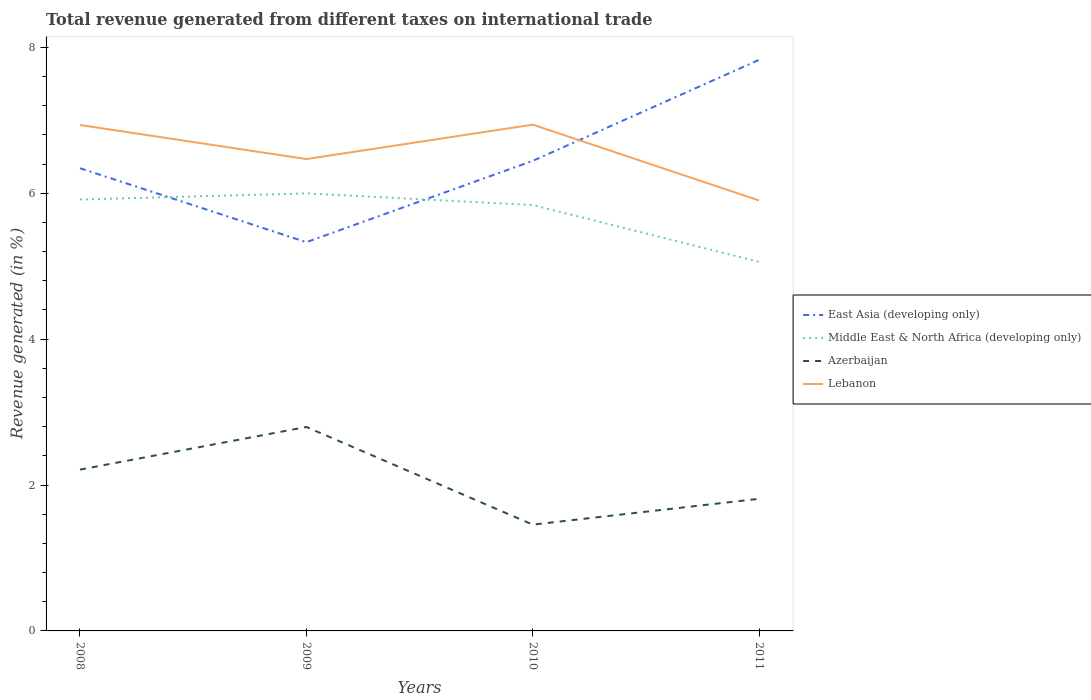How many different coloured lines are there?
Provide a short and direct response. 4. Across all years, what is the maximum total revenue generated in Azerbaijan?
Provide a succinct answer. 1.46. What is the total total revenue generated in East Asia (developing only) in the graph?
Provide a short and direct response. 1.01. What is the difference between the highest and the second highest total revenue generated in Middle East & North Africa (developing only)?
Your answer should be very brief. 0.94. What is the difference between the highest and the lowest total revenue generated in Azerbaijan?
Keep it short and to the point. 2. Is the total revenue generated in Middle East & North Africa (developing only) strictly greater than the total revenue generated in Azerbaijan over the years?
Make the answer very short. No. How many lines are there?
Ensure brevity in your answer.  4. Are the values on the major ticks of Y-axis written in scientific E-notation?
Offer a terse response. No. Does the graph contain any zero values?
Give a very brief answer. No. How many legend labels are there?
Give a very brief answer. 4. How are the legend labels stacked?
Provide a succinct answer. Vertical. What is the title of the graph?
Provide a short and direct response. Total revenue generated from different taxes on international trade. What is the label or title of the X-axis?
Make the answer very short. Years. What is the label or title of the Y-axis?
Offer a terse response. Revenue generated (in %). What is the Revenue generated (in %) in East Asia (developing only) in 2008?
Provide a short and direct response. 6.34. What is the Revenue generated (in %) of Middle East & North Africa (developing only) in 2008?
Your answer should be compact. 5.91. What is the Revenue generated (in %) in Azerbaijan in 2008?
Provide a succinct answer. 2.21. What is the Revenue generated (in %) in Lebanon in 2008?
Offer a terse response. 6.93. What is the Revenue generated (in %) of East Asia (developing only) in 2009?
Offer a terse response. 5.33. What is the Revenue generated (in %) in Middle East & North Africa (developing only) in 2009?
Ensure brevity in your answer.  6. What is the Revenue generated (in %) of Azerbaijan in 2009?
Offer a terse response. 2.8. What is the Revenue generated (in %) of Lebanon in 2009?
Keep it short and to the point. 6.47. What is the Revenue generated (in %) in East Asia (developing only) in 2010?
Your answer should be compact. 6.44. What is the Revenue generated (in %) of Middle East & North Africa (developing only) in 2010?
Make the answer very short. 5.84. What is the Revenue generated (in %) of Azerbaijan in 2010?
Keep it short and to the point. 1.46. What is the Revenue generated (in %) in Lebanon in 2010?
Give a very brief answer. 6.94. What is the Revenue generated (in %) in East Asia (developing only) in 2011?
Offer a very short reply. 7.83. What is the Revenue generated (in %) of Middle East & North Africa (developing only) in 2011?
Your answer should be compact. 5.06. What is the Revenue generated (in %) of Azerbaijan in 2011?
Make the answer very short. 1.81. What is the Revenue generated (in %) in Lebanon in 2011?
Provide a short and direct response. 5.9. Across all years, what is the maximum Revenue generated (in %) of East Asia (developing only)?
Provide a succinct answer. 7.83. Across all years, what is the maximum Revenue generated (in %) in Middle East & North Africa (developing only)?
Your answer should be compact. 6. Across all years, what is the maximum Revenue generated (in %) in Azerbaijan?
Keep it short and to the point. 2.8. Across all years, what is the maximum Revenue generated (in %) in Lebanon?
Your answer should be very brief. 6.94. Across all years, what is the minimum Revenue generated (in %) of East Asia (developing only)?
Offer a terse response. 5.33. Across all years, what is the minimum Revenue generated (in %) in Middle East & North Africa (developing only)?
Offer a very short reply. 5.06. Across all years, what is the minimum Revenue generated (in %) of Azerbaijan?
Your answer should be compact. 1.46. Across all years, what is the minimum Revenue generated (in %) of Lebanon?
Provide a short and direct response. 5.9. What is the total Revenue generated (in %) of East Asia (developing only) in the graph?
Provide a short and direct response. 25.94. What is the total Revenue generated (in %) in Middle East & North Africa (developing only) in the graph?
Make the answer very short. 22.81. What is the total Revenue generated (in %) of Azerbaijan in the graph?
Your answer should be compact. 8.28. What is the total Revenue generated (in %) in Lebanon in the graph?
Make the answer very short. 26.24. What is the difference between the Revenue generated (in %) of East Asia (developing only) in 2008 and that in 2009?
Provide a succinct answer. 1.01. What is the difference between the Revenue generated (in %) of Middle East & North Africa (developing only) in 2008 and that in 2009?
Your answer should be very brief. -0.08. What is the difference between the Revenue generated (in %) of Azerbaijan in 2008 and that in 2009?
Your answer should be very brief. -0.58. What is the difference between the Revenue generated (in %) of Lebanon in 2008 and that in 2009?
Keep it short and to the point. 0.47. What is the difference between the Revenue generated (in %) of East Asia (developing only) in 2008 and that in 2010?
Offer a very short reply. -0.1. What is the difference between the Revenue generated (in %) of Middle East & North Africa (developing only) in 2008 and that in 2010?
Your answer should be compact. 0.08. What is the difference between the Revenue generated (in %) of Azerbaijan in 2008 and that in 2010?
Provide a succinct answer. 0.75. What is the difference between the Revenue generated (in %) of Lebanon in 2008 and that in 2010?
Offer a very short reply. -0. What is the difference between the Revenue generated (in %) in East Asia (developing only) in 2008 and that in 2011?
Offer a terse response. -1.49. What is the difference between the Revenue generated (in %) of Middle East & North Africa (developing only) in 2008 and that in 2011?
Keep it short and to the point. 0.86. What is the difference between the Revenue generated (in %) of Lebanon in 2008 and that in 2011?
Your response must be concise. 1.03. What is the difference between the Revenue generated (in %) in East Asia (developing only) in 2009 and that in 2010?
Your answer should be very brief. -1.12. What is the difference between the Revenue generated (in %) in Middle East & North Africa (developing only) in 2009 and that in 2010?
Make the answer very short. 0.16. What is the difference between the Revenue generated (in %) in Azerbaijan in 2009 and that in 2010?
Your response must be concise. 1.34. What is the difference between the Revenue generated (in %) of Lebanon in 2009 and that in 2010?
Offer a terse response. -0.47. What is the difference between the Revenue generated (in %) of East Asia (developing only) in 2009 and that in 2011?
Your answer should be very brief. -2.5. What is the difference between the Revenue generated (in %) of Middle East & North Africa (developing only) in 2009 and that in 2011?
Ensure brevity in your answer.  0.94. What is the difference between the Revenue generated (in %) of Azerbaijan in 2009 and that in 2011?
Offer a very short reply. 0.98. What is the difference between the Revenue generated (in %) of Lebanon in 2009 and that in 2011?
Give a very brief answer. 0.57. What is the difference between the Revenue generated (in %) in East Asia (developing only) in 2010 and that in 2011?
Offer a very short reply. -1.38. What is the difference between the Revenue generated (in %) in Middle East & North Africa (developing only) in 2010 and that in 2011?
Give a very brief answer. 0.78. What is the difference between the Revenue generated (in %) in Azerbaijan in 2010 and that in 2011?
Ensure brevity in your answer.  -0.35. What is the difference between the Revenue generated (in %) of Lebanon in 2010 and that in 2011?
Your answer should be very brief. 1.04. What is the difference between the Revenue generated (in %) in East Asia (developing only) in 2008 and the Revenue generated (in %) in Middle East & North Africa (developing only) in 2009?
Keep it short and to the point. 0.34. What is the difference between the Revenue generated (in %) of East Asia (developing only) in 2008 and the Revenue generated (in %) of Azerbaijan in 2009?
Your response must be concise. 3.55. What is the difference between the Revenue generated (in %) in East Asia (developing only) in 2008 and the Revenue generated (in %) in Lebanon in 2009?
Make the answer very short. -0.13. What is the difference between the Revenue generated (in %) in Middle East & North Africa (developing only) in 2008 and the Revenue generated (in %) in Azerbaijan in 2009?
Make the answer very short. 3.12. What is the difference between the Revenue generated (in %) of Middle East & North Africa (developing only) in 2008 and the Revenue generated (in %) of Lebanon in 2009?
Keep it short and to the point. -0.55. What is the difference between the Revenue generated (in %) in Azerbaijan in 2008 and the Revenue generated (in %) in Lebanon in 2009?
Offer a very short reply. -4.26. What is the difference between the Revenue generated (in %) in East Asia (developing only) in 2008 and the Revenue generated (in %) in Middle East & North Africa (developing only) in 2010?
Make the answer very short. 0.5. What is the difference between the Revenue generated (in %) of East Asia (developing only) in 2008 and the Revenue generated (in %) of Azerbaijan in 2010?
Offer a terse response. 4.89. What is the difference between the Revenue generated (in %) of East Asia (developing only) in 2008 and the Revenue generated (in %) of Lebanon in 2010?
Make the answer very short. -0.6. What is the difference between the Revenue generated (in %) in Middle East & North Africa (developing only) in 2008 and the Revenue generated (in %) in Azerbaijan in 2010?
Your answer should be very brief. 4.46. What is the difference between the Revenue generated (in %) in Middle East & North Africa (developing only) in 2008 and the Revenue generated (in %) in Lebanon in 2010?
Offer a very short reply. -1.03. What is the difference between the Revenue generated (in %) in Azerbaijan in 2008 and the Revenue generated (in %) in Lebanon in 2010?
Your response must be concise. -4.73. What is the difference between the Revenue generated (in %) in East Asia (developing only) in 2008 and the Revenue generated (in %) in Middle East & North Africa (developing only) in 2011?
Keep it short and to the point. 1.28. What is the difference between the Revenue generated (in %) of East Asia (developing only) in 2008 and the Revenue generated (in %) of Azerbaijan in 2011?
Your response must be concise. 4.53. What is the difference between the Revenue generated (in %) in East Asia (developing only) in 2008 and the Revenue generated (in %) in Lebanon in 2011?
Your answer should be compact. 0.44. What is the difference between the Revenue generated (in %) of Middle East & North Africa (developing only) in 2008 and the Revenue generated (in %) of Azerbaijan in 2011?
Ensure brevity in your answer.  4.1. What is the difference between the Revenue generated (in %) in Middle East & North Africa (developing only) in 2008 and the Revenue generated (in %) in Lebanon in 2011?
Your response must be concise. 0.01. What is the difference between the Revenue generated (in %) of Azerbaijan in 2008 and the Revenue generated (in %) of Lebanon in 2011?
Offer a very short reply. -3.69. What is the difference between the Revenue generated (in %) of East Asia (developing only) in 2009 and the Revenue generated (in %) of Middle East & North Africa (developing only) in 2010?
Keep it short and to the point. -0.51. What is the difference between the Revenue generated (in %) of East Asia (developing only) in 2009 and the Revenue generated (in %) of Azerbaijan in 2010?
Offer a terse response. 3.87. What is the difference between the Revenue generated (in %) of East Asia (developing only) in 2009 and the Revenue generated (in %) of Lebanon in 2010?
Ensure brevity in your answer.  -1.61. What is the difference between the Revenue generated (in %) in Middle East & North Africa (developing only) in 2009 and the Revenue generated (in %) in Azerbaijan in 2010?
Provide a succinct answer. 4.54. What is the difference between the Revenue generated (in %) of Middle East & North Africa (developing only) in 2009 and the Revenue generated (in %) of Lebanon in 2010?
Your response must be concise. -0.94. What is the difference between the Revenue generated (in %) of Azerbaijan in 2009 and the Revenue generated (in %) of Lebanon in 2010?
Your answer should be very brief. -4.14. What is the difference between the Revenue generated (in %) in East Asia (developing only) in 2009 and the Revenue generated (in %) in Middle East & North Africa (developing only) in 2011?
Offer a very short reply. 0.27. What is the difference between the Revenue generated (in %) of East Asia (developing only) in 2009 and the Revenue generated (in %) of Azerbaijan in 2011?
Offer a terse response. 3.52. What is the difference between the Revenue generated (in %) in East Asia (developing only) in 2009 and the Revenue generated (in %) in Lebanon in 2011?
Your response must be concise. -0.57. What is the difference between the Revenue generated (in %) of Middle East & North Africa (developing only) in 2009 and the Revenue generated (in %) of Azerbaijan in 2011?
Keep it short and to the point. 4.19. What is the difference between the Revenue generated (in %) of Middle East & North Africa (developing only) in 2009 and the Revenue generated (in %) of Lebanon in 2011?
Your answer should be very brief. 0.1. What is the difference between the Revenue generated (in %) in Azerbaijan in 2009 and the Revenue generated (in %) in Lebanon in 2011?
Your answer should be compact. -3.1. What is the difference between the Revenue generated (in %) of East Asia (developing only) in 2010 and the Revenue generated (in %) of Middle East & North Africa (developing only) in 2011?
Make the answer very short. 1.39. What is the difference between the Revenue generated (in %) of East Asia (developing only) in 2010 and the Revenue generated (in %) of Azerbaijan in 2011?
Give a very brief answer. 4.63. What is the difference between the Revenue generated (in %) of East Asia (developing only) in 2010 and the Revenue generated (in %) of Lebanon in 2011?
Offer a terse response. 0.54. What is the difference between the Revenue generated (in %) in Middle East & North Africa (developing only) in 2010 and the Revenue generated (in %) in Azerbaijan in 2011?
Your answer should be compact. 4.03. What is the difference between the Revenue generated (in %) in Middle East & North Africa (developing only) in 2010 and the Revenue generated (in %) in Lebanon in 2011?
Offer a very short reply. -0.06. What is the difference between the Revenue generated (in %) of Azerbaijan in 2010 and the Revenue generated (in %) of Lebanon in 2011?
Offer a terse response. -4.44. What is the average Revenue generated (in %) in East Asia (developing only) per year?
Provide a succinct answer. 6.49. What is the average Revenue generated (in %) of Middle East & North Africa (developing only) per year?
Offer a very short reply. 5.7. What is the average Revenue generated (in %) of Azerbaijan per year?
Your response must be concise. 2.07. What is the average Revenue generated (in %) in Lebanon per year?
Keep it short and to the point. 6.56. In the year 2008, what is the difference between the Revenue generated (in %) in East Asia (developing only) and Revenue generated (in %) in Middle East & North Africa (developing only)?
Give a very brief answer. 0.43. In the year 2008, what is the difference between the Revenue generated (in %) in East Asia (developing only) and Revenue generated (in %) in Azerbaijan?
Make the answer very short. 4.13. In the year 2008, what is the difference between the Revenue generated (in %) in East Asia (developing only) and Revenue generated (in %) in Lebanon?
Make the answer very short. -0.59. In the year 2008, what is the difference between the Revenue generated (in %) in Middle East & North Africa (developing only) and Revenue generated (in %) in Azerbaijan?
Make the answer very short. 3.7. In the year 2008, what is the difference between the Revenue generated (in %) of Middle East & North Africa (developing only) and Revenue generated (in %) of Lebanon?
Offer a very short reply. -1.02. In the year 2008, what is the difference between the Revenue generated (in %) in Azerbaijan and Revenue generated (in %) in Lebanon?
Give a very brief answer. -4.72. In the year 2009, what is the difference between the Revenue generated (in %) of East Asia (developing only) and Revenue generated (in %) of Middle East & North Africa (developing only)?
Make the answer very short. -0.67. In the year 2009, what is the difference between the Revenue generated (in %) in East Asia (developing only) and Revenue generated (in %) in Azerbaijan?
Provide a succinct answer. 2.53. In the year 2009, what is the difference between the Revenue generated (in %) of East Asia (developing only) and Revenue generated (in %) of Lebanon?
Make the answer very short. -1.14. In the year 2009, what is the difference between the Revenue generated (in %) in Middle East & North Africa (developing only) and Revenue generated (in %) in Azerbaijan?
Give a very brief answer. 3.2. In the year 2009, what is the difference between the Revenue generated (in %) of Middle East & North Africa (developing only) and Revenue generated (in %) of Lebanon?
Provide a succinct answer. -0.47. In the year 2009, what is the difference between the Revenue generated (in %) of Azerbaijan and Revenue generated (in %) of Lebanon?
Keep it short and to the point. -3.67. In the year 2010, what is the difference between the Revenue generated (in %) in East Asia (developing only) and Revenue generated (in %) in Middle East & North Africa (developing only)?
Give a very brief answer. 0.61. In the year 2010, what is the difference between the Revenue generated (in %) in East Asia (developing only) and Revenue generated (in %) in Azerbaijan?
Provide a succinct answer. 4.99. In the year 2010, what is the difference between the Revenue generated (in %) of East Asia (developing only) and Revenue generated (in %) of Lebanon?
Offer a very short reply. -0.5. In the year 2010, what is the difference between the Revenue generated (in %) in Middle East & North Africa (developing only) and Revenue generated (in %) in Azerbaijan?
Your answer should be very brief. 4.38. In the year 2010, what is the difference between the Revenue generated (in %) of Middle East & North Africa (developing only) and Revenue generated (in %) of Lebanon?
Your answer should be compact. -1.1. In the year 2010, what is the difference between the Revenue generated (in %) of Azerbaijan and Revenue generated (in %) of Lebanon?
Offer a terse response. -5.48. In the year 2011, what is the difference between the Revenue generated (in %) in East Asia (developing only) and Revenue generated (in %) in Middle East & North Africa (developing only)?
Provide a short and direct response. 2.77. In the year 2011, what is the difference between the Revenue generated (in %) in East Asia (developing only) and Revenue generated (in %) in Azerbaijan?
Provide a succinct answer. 6.02. In the year 2011, what is the difference between the Revenue generated (in %) in East Asia (developing only) and Revenue generated (in %) in Lebanon?
Offer a terse response. 1.93. In the year 2011, what is the difference between the Revenue generated (in %) of Middle East & North Africa (developing only) and Revenue generated (in %) of Azerbaijan?
Offer a very short reply. 3.25. In the year 2011, what is the difference between the Revenue generated (in %) of Middle East & North Africa (developing only) and Revenue generated (in %) of Lebanon?
Give a very brief answer. -0.84. In the year 2011, what is the difference between the Revenue generated (in %) of Azerbaijan and Revenue generated (in %) of Lebanon?
Offer a terse response. -4.09. What is the ratio of the Revenue generated (in %) in East Asia (developing only) in 2008 to that in 2009?
Ensure brevity in your answer.  1.19. What is the ratio of the Revenue generated (in %) of Middle East & North Africa (developing only) in 2008 to that in 2009?
Your answer should be very brief. 0.99. What is the ratio of the Revenue generated (in %) of Azerbaijan in 2008 to that in 2009?
Provide a succinct answer. 0.79. What is the ratio of the Revenue generated (in %) of Lebanon in 2008 to that in 2009?
Offer a terse response. 1.07. What is the ratio of the Revenue generated (in %) of East Asia (developing only) in 2008 to that in 2010?
Keep it short and to the point. 0.98. What is the ratio of the Revenue generated (in %) in Middle East & North Africa (developing only) in 2008 to that in 2010?
Make the answer very short. 1.01. What is the ratio of the Revenue generated (in %) of Azerbaijan in 2008 to that in 2010?
Keep it short and to the point. 1.52. What is the ratio of the Revenue generated (in %) of Lebanon in 2008 to that in 2010?
Make the answer very short. 1. What is the ratio of the Revenue generated (in %) of East Asia (developing only) in 2008 to that in 2011?
Your response must be concise. 0.81. What is the ratio of the Revenue generated (in %) in Middle East & North Africa (developing only) in 2008 to that in 2011?
Your answer should be compact. 1.17. What is the ratio of the Revenue generated (in %) in Azerbaijan in 2008 to that in 2011?
Provide a short and direct response. 1.22. What is the ratio of the Revenue generated (in %) of Lebanon in 2008 to that in 2011?
Keep it short and to the point. 1.18. What is the ratio of the Revenue generated (in %) in East Asia (developing only) in 2009 to that in 2010?
Provide a short and direct response. 0.83. What is the ratio of the Revenue generated (in %) of Middle East & North Africa (developing only) in 2009 to that in 2010?
Keep it short and to the point. 1.03. What is the ratio of the Revenue generated (in %) in Azerbaijan in 2009 to that in 2010?
Offer a very short reply. 1.92. What is the ratio of the Revenue generated (in %) in Lebanon in 2009 to that in 2010?
Ensure brevity in your answer.  0.93. What is the ratio of the Revenue generated (in %) in East Asia (developing only) in 2009 to that in 2011?
Your answer should be very brief. 0.68. What is the ratio of the Revenue generated (in %) of Middle East & North Africa (developing only) in 2009 to that in 2011?
Provide a succinct answer. 1.19. What is the ratio of the Revenue generated (in %) in Azerbaijan in 2009 to that in 2011?
Your answer should be very brief. 1.54. What is the ratio of the Revenue generated (in %) in Lebanon in 2009 to that in 2011?
Keep it short and to the point. 1.1. What is the ratio of the Revenue generated (in %) in East Asia (developing only) in 2010 to that in 2011?
Ensure brevity in your answer.  0.82. What is the ratio of the Revenue generated (in %) of Middle East & North Africa (developing only) in 2010 to that in 2011?
Ensure brevity in your answer.  1.15. What is the ratio of the Revenue generated (in %) in Azerbaijan in 2010 to that in 2011?
Your answer should be compact. 0.8. What is the ratio of the Revenue generated (in %) in Lebanon in 2010 to that in 2011?
Your answer should be compact. 1.18. What is the difference between the highest and the second highest Revenue generated (in %) in East Asia (developing only)?
Your answer should be very brief. 1.38. What is the difference between the highest and the second highest Revenue generated (in %) of Middle East & North Africa (developing only)?
Make the answer very short. 0.08. What is the difference between the highest and the second highest Revenue generated (in %) in Azerbaijan?
Offer a very short reply. 0.58. What is the difference between the highest and the second highest Revenue generated (in %) in Lebanon?
Provide a short and direct response. 0. What is the difference between the highest and the lowest Revenue generated (in %) in East Asia (developing only)?
Your answer should be very brief. 2.5. What is the difference between the highest and the lowest Revenue generated (in %) in Middle East & North Africa (developing only)?
Your response must be concise. 0.94. What is the difference between the highest and the lowest Revenue generated (in %) of Azerbaijan?
Your answer should be very brief. 1.34. What is the difference between the highest and the lowest Revenue generated (in %) of Lebanon?
Your answer should be very brief. 1.04. 